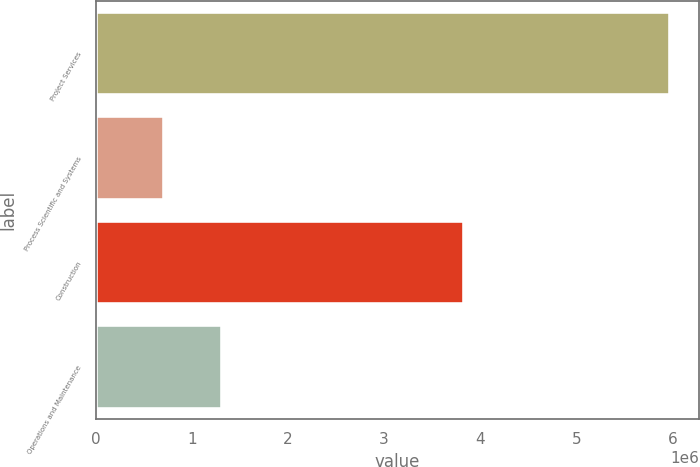Convert chart to OTSL. <chart><loc_0><loc_0><loc_500><loc_500><bar_chart><fcel>Project Services<fcel>Process Scientific and Systems<fcel>Construction<fcel>Operations and Maintenance<nl><fcel>5.97792e+06<fcel>705694<fcel>3.82588e+06<fcel>1.30889e+06<nl></chart> 